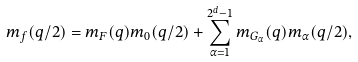Convert formula to latex. <formula><loc_0><loc_0><loc_500><loc_500>m _ { f } ( q / 2 ) = m _ { F } ( q ) m _ { 0 } ( q / 2 ) + \sum _ { \alpha = 1 } ^ { 2 ^ { d } - 1 } m _ { G _ { \alpha } } ( q ) m _ { \alpha } ( q / 2 ) ,</formula> 